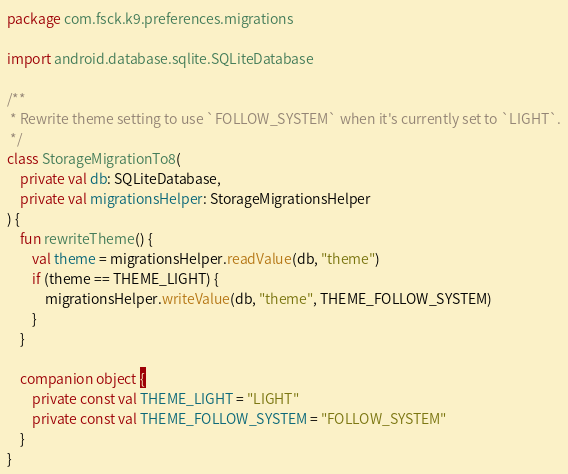<code> <loc_0><loc_0><loc_500><loc_500><_Kotlin_>package com.fsck.k9.preferences.migrations

import android.database.sqlite.SQLiteDatabase

/**
 * Rewrite theme setting to use `FOLLOW_SYSTEM` when it's currently set to `LIGHT`.
 */
class StorageMigrationTo8(
    private val db: SQLiteDatabase,
    private val migrationsHelper: StorageMigrationsHelper
) {
    fun rewriteTheme() {
        val theme = migrationsHelper.readValue(db, "theme")
        if (theme == THEME_LIGHT) {
            migrationsHelper.writeValue(db, "theme", THEME_FOLLOW_SYSTEM)
        }
    }

    companion object {
        private const val THEME_LIGHT = "LIGHT"
        private const val THEME_FOLLOW_SYSTEM = "FOLLOW_SYSTEM"
    }
}
</code> 